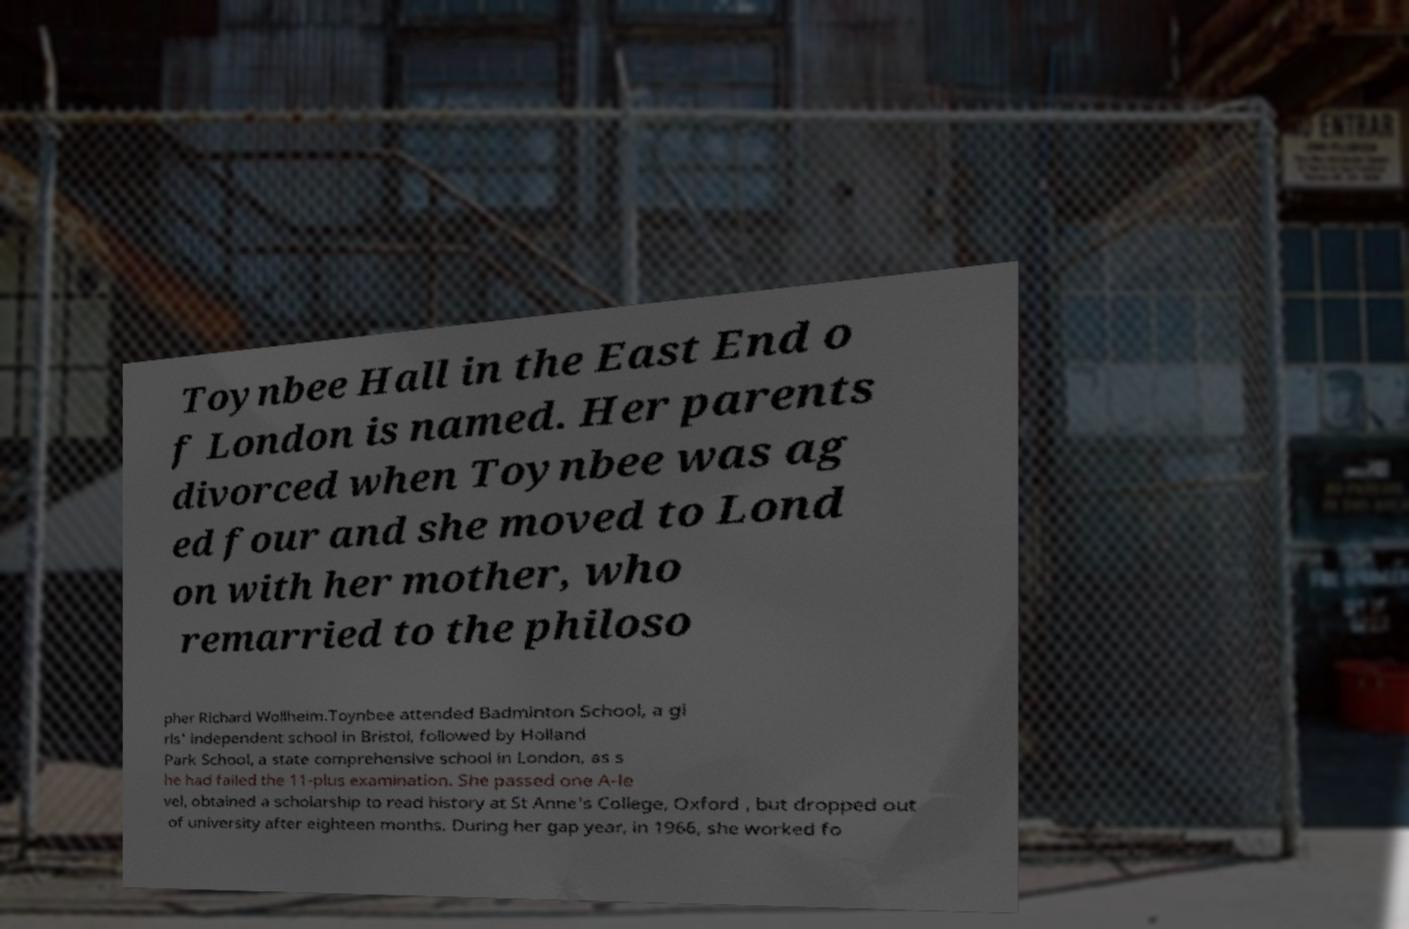Please identify and transcribe the text found in this image. Toynbee Hall in the East End o f London is named. Her parents divorced when Toynbee was ag ed four and she moved to Lond on with her mother, who remarried to the philoso pher Richard Wollheim.Toynbee attended Badminton School, a gi rls' independent school in Bristol, followed by Holland Park School, a state comprehensive school in London, as s he had failed the 11-plus examination. She passed one A-le vel, obtained a scholarship to read history at St Anne's College, Oxford , but dropped out of university after eighteen months. During her gap year, in 1966, she worked fo 